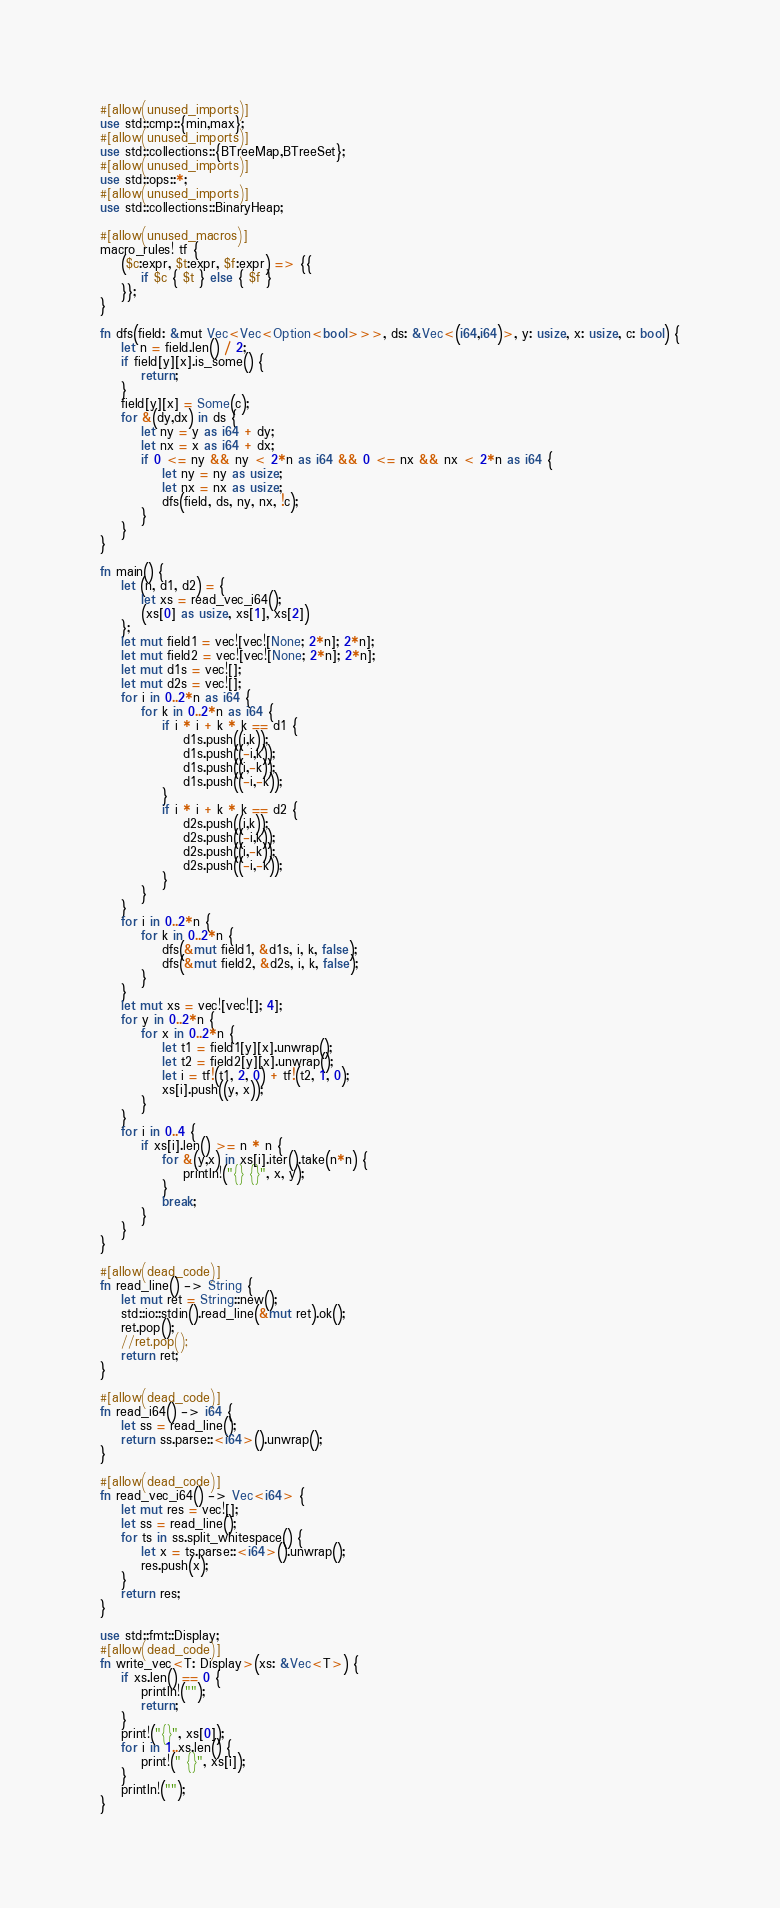Convert code to text. <code><loc_0><loc_0><loc_500><loc_500><_Rust_>#[allow(unused_imports)]
use std::cmp::{min,max};
#[allow(unused_imports)]
use std::collections::{BTreeMap,BTreeSet};
#[allow(unused_imports)]
use std::ops::*;
#[allow(unused_imports)]
use std::collections::BinaryHeap;

#[allow(unused_macros)]
macro_rules! tf {
    ($c:expr, $t:expr, $f:expr) => {{
        if $c { $t } else { $f }
    }};
}

fn dfs(field: &mut Vec<Vec<Option<bool>>>, ds: &Vec<(i64,i64)>, y: usize, x: usize, c: bool) {
    let n = field.len() / 2;
    if field[y][x].is_some() {
        return;
    }
    field[y][x] = Some(c);
    for &(dy,dx) in ds {
        let ny = y as i64 + dy;
        let nx = x as i64 + dx;
        if 0 <= ny && ny < 2*n as i64 && 0 <= nx && nx < 2*n as i64 {
            let ny = ny as usize;
            let nx = nx as usize;
            dfs(field, ds, ny, nx, !c);
        }
    }
}

fn main() {
    let (n, d1, d2) = {
        let xs = read_vec_i64();
        (xs[0] as usize, xs[1], xs[2])
    };
    let mut field1 = vec![vec![None; 2*n]; 2*n];
    let mut field2 = vec![vec![None; 2*n]; 2*n];
    let mut d1s = vec![];
    let mut d2s = vec![];
    for i in 0..2*n as i64 {
        for k in 0..2*n as i64 {
            if i * i + k * k == d1 {
                d1s.push((i,k));
                d1s.push((-i,k));
                d1s.push((i,-k));
                d1s.push((-i,-k));
            }
            if i * i + k * k == d2 {
                d2s.push((i,k));
                d2s.push((-i,k));
                d2s.push((i,-k));
                d2s.push((-i,-k));
            }
        }
    }
    for i in 0..2*n {
        for k in 0..2*n {
            dfs(&mut field1, &d1s, i, k, false);
            dfs(&mut field2, &d2s, i, k, false);
        }
    }
    let mut xs = vec![vec![]; 4];
    for y in 0..2*n {
        for x in 0..2*n {
            let t1 = field1[y][x].unwrap();
            let t2 = field2[y][x].unwrap();
            let i = tf!(t1, 2, 0) + tf!(t2, 1, 0);
            xs[i].push((y, x));
        }
    }
    for i in 0..4 {
        if xs[i].len() >= n * n {
            for &(y,x) in xs[i].iter().take(n*n) {
                println!("{} {}", x, y);
            }
            break;
        }
    }
}

#[allow(dead_code)]
fn read_line() -> String {
    let mut ret = String::new();
    std::io::stdin().read_line(&mut ret).ok();
    ret.pop();
    //ret.pop();
    return ret;
}

#[allow(dead_code)]
fn read_i64() -> i64 {
    let ss = read_line();
    return ss.parse::<i64>().unwrap();
}

#[allow(dead_code)]
fn read_vec_i64() -> Vec<i64> {
    let mut res = vec![];
    let ss = read_line();
    for ts in ss.split_whitespace() {
        let x = ts.parse::<i64>().unwrap();
        res.push(x);
    }
    return res;
}

use std::fmt::Display;
#[allow(dead_code)]
fn write_vec<T: Display>(xs: &Vec<T>) {
    if xs.len() == 0 {
        println!("");
        return;
    }
    print!("{}", xs[0]);
    for i in 1..xs.len() {
        print!(" {}", xs[i]);
    }
    println!("");
}
</code> 